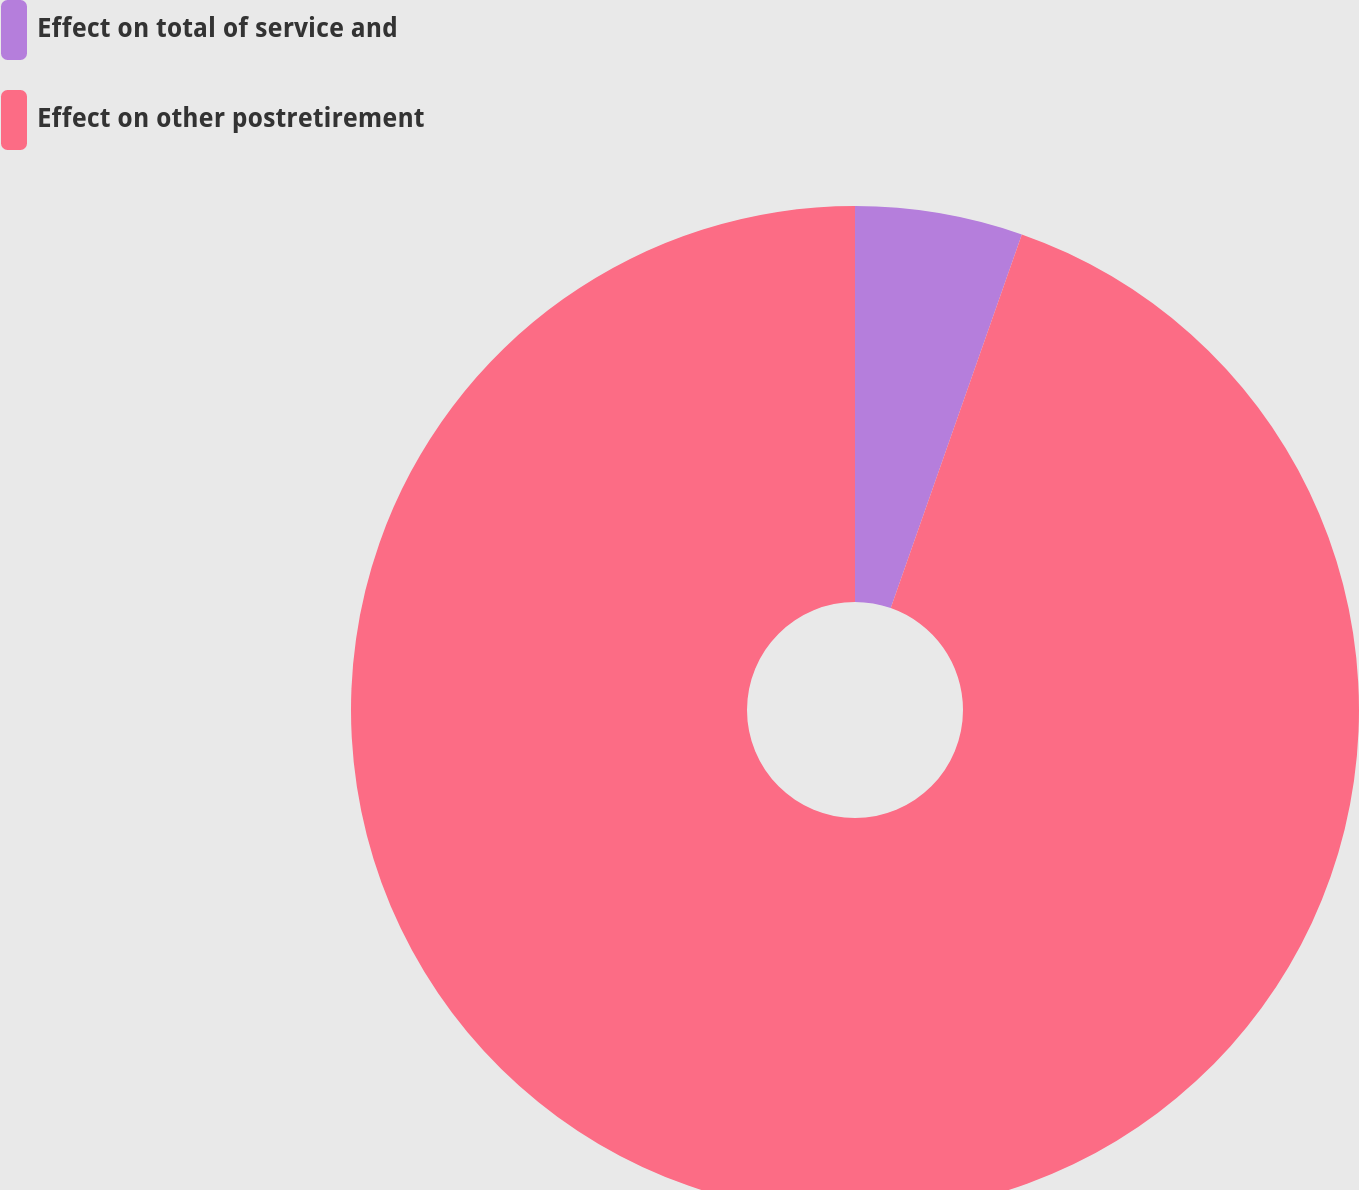Convert chart. <chart><loc_0><loc_0><loc_500><loc_500><pie_chart><fcel>Effect on total of service and<fcel>Effect on other postretirement<nl><fcel>5.37%<fcel>94.63%<nl></chart> 